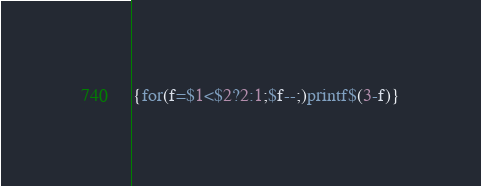<code> <loc_0><loc_0><loc_500><loc_500><_Awk_>{for(f=$1<$2?2:1;$f--;)printf$(3-f)}</code> 